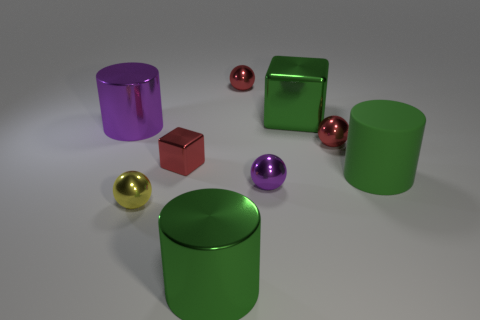Subtract all tiny yellow spheres. How many spheres are left? 3 Subtract all purple cylinders. How many cylinders are left? 2 Add 3 small metallic cubes. How many small metallic cubes are left? 4 Add 2 big green metal cylinders. How many big green metal cylinders exist? 3 Subtract 1 green cylinders. How many objects are left? 8 Subtract all spheres. How many objects are left? 5 Subtract 4 balls. How many balls are left? 0 Subtract all green cylinders. Subtract all cyan cubes. How many cylinders are left? 1 Subtract all blue cubes. How many green cylinders are left? 2 Subtract all large cubes. Subtract all large purple blocks. How many objects are left? 8 